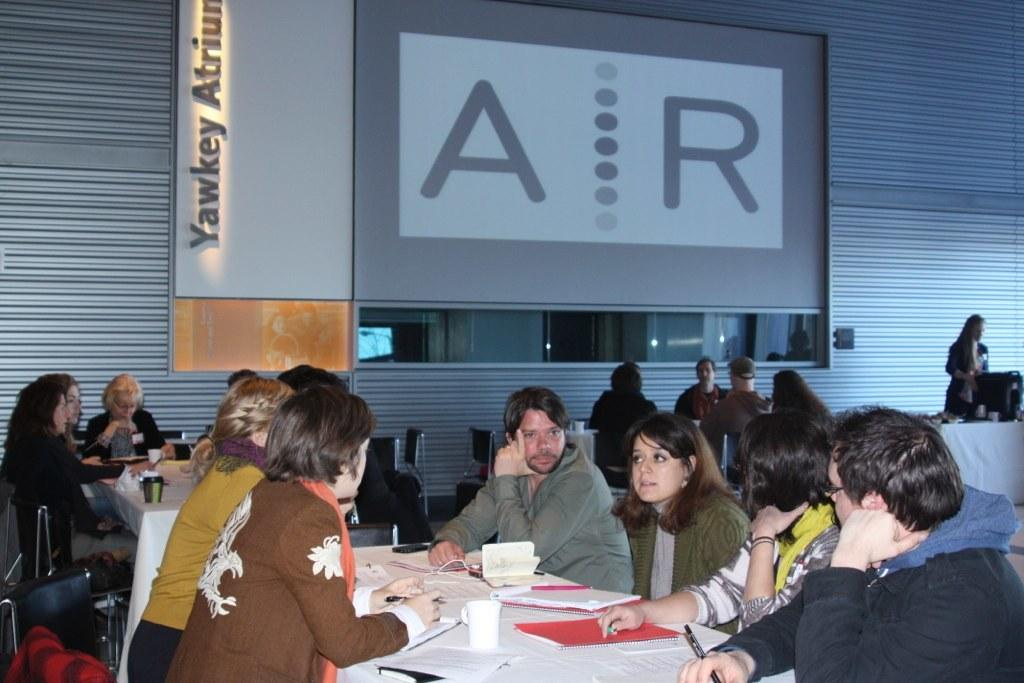What are the people in the image doing? The people in the image are sitting on chairs near a table. What items can be seen on the table? There are books, papers, and cups on the table. What is visible in the background of the image? There is a wall visible in the background. What type of skin condition can be seen on the people in the image? There is no indication of any skin condition on the people in the image. What kind of umbrella is being used by the people in the image? There is no umbrella present in the image. 